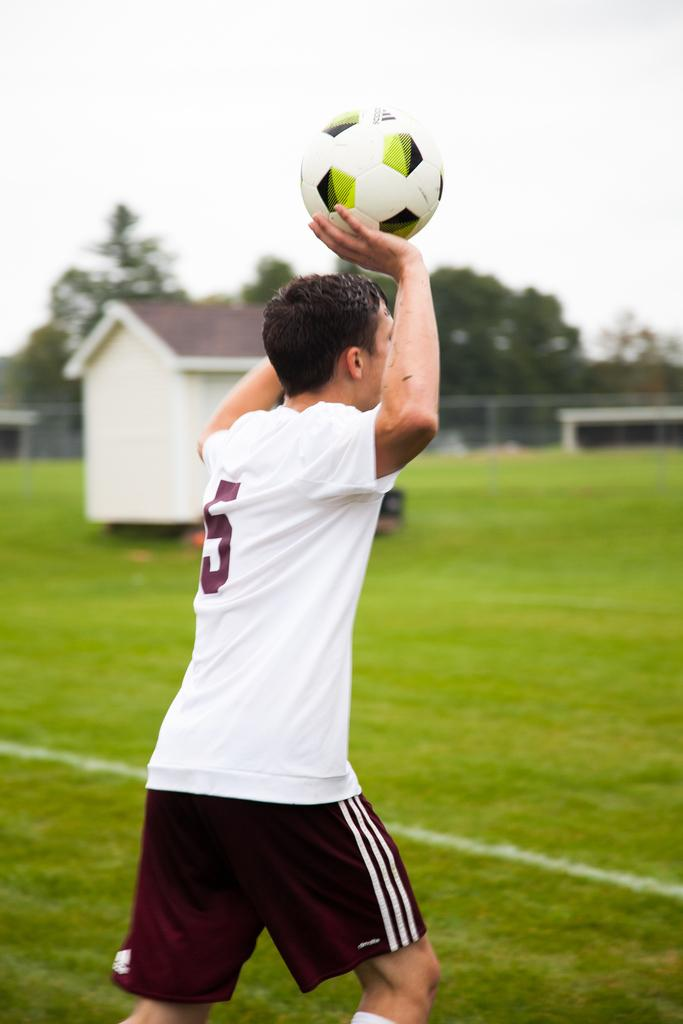Who is present in the image? There is a man in the image. What is the man holding in the image? The man is holding a football. What type of natural environment can be seen in the image? There are trees visible in the image. What type of structure is present in the image? There is a house in the image. How many chairs can be seen in the image? There are no chairs visible in the image. What type of bone is the man holding in the image? There is no bone present in the image; the man is holding a football. 